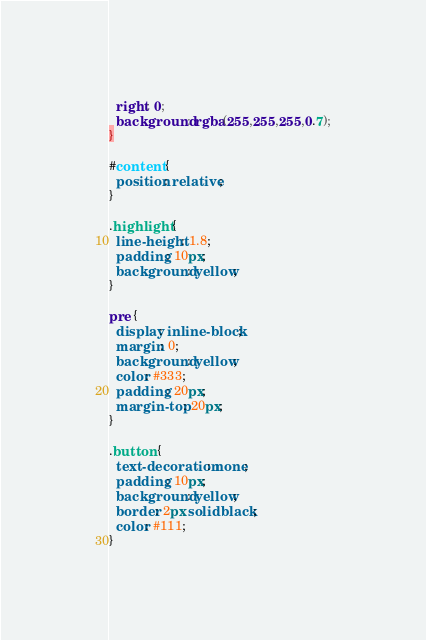<code> <loc_0><loc_0><loc_500><loc_500><_CSS_>  right: 0;
  background: rgba(255,255,255,0.7);
}

#content {
  position: relative;
}

.highlight {
  line-height: 1.8;
  padding: 10px;
  background: yellow;
}

pre {
  display: inline-block;
  margin: 0;
  background: yellow;
  color: #333;
  padding: 20px;
  margin-top: 20px;
}

.button {
  text-decoration: none;
  padding: 10px;
  background: yellow;
  border: 2px solid black;
  color: #111;
}
</code> 